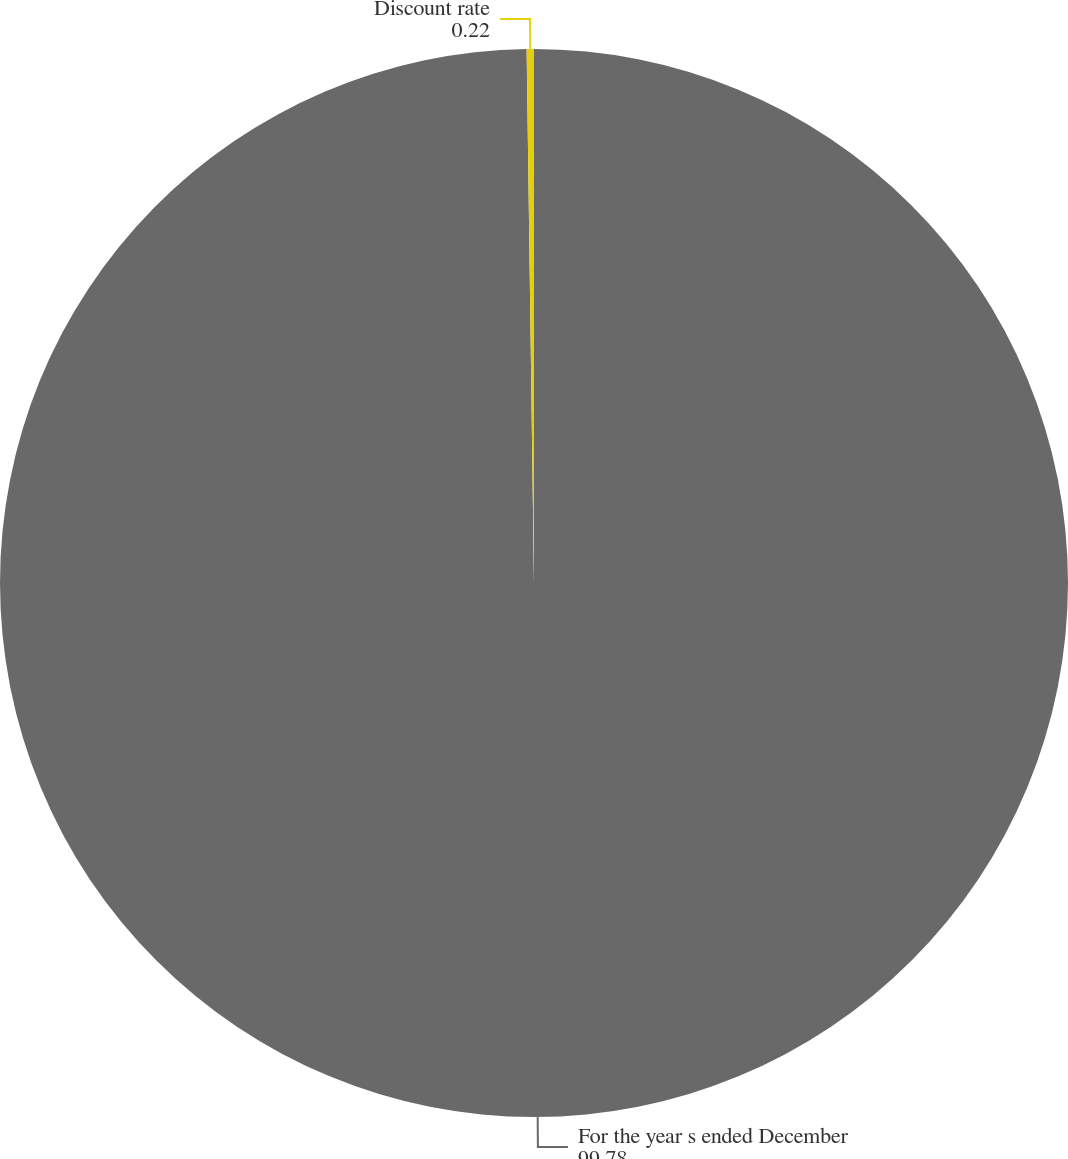Convert chart. <chart><loc_0><loc_0><loc_500><loc_500><pie_chart><fcel>For the year s ended December<fcel>Discount rate<nl><fcel>99.78%<fcel>0.22%<nl></chart> 